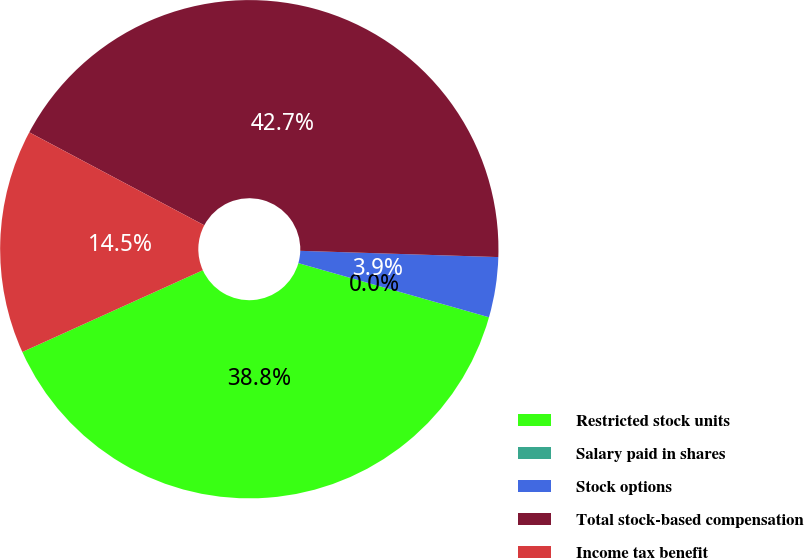<chart> <loc_0><loc_0><loc_500><loc_500><pie_chart><fcel>Restricted stock units<fcel>Salary paid in shares<fcel>Stock options<fcel>Total stock-based compensation<fcel>Income tax benefit<nl><fcel>38.83%<fcel>0.0%<fcel>3.9%<fcel>42.73%<fcel>14.54%<nl></chart> 